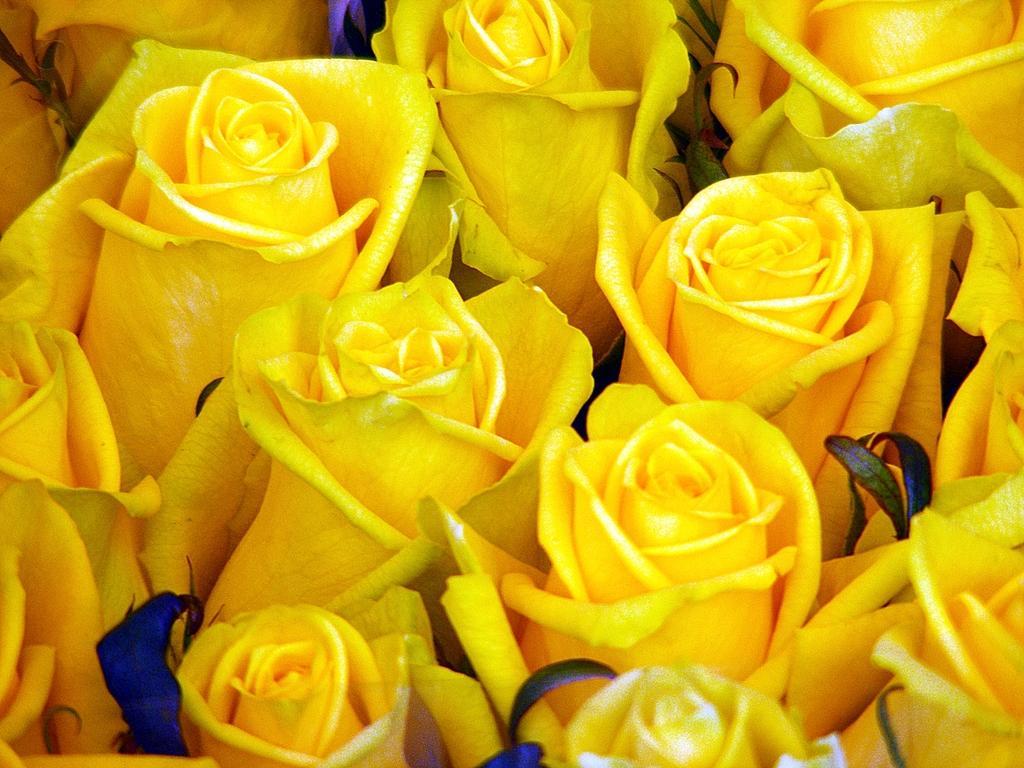Can you describe this image briefly? In this picture I can see cluster of yellow roses. 